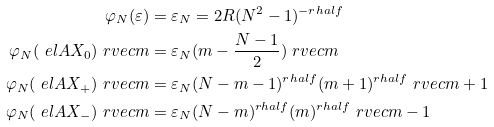Convert formula to latex. <formula><loc_0><loc_0><loc_500><loc_500>\varphi _ { N } ( \varepsilon ) & = \varepsilon _ { N } = 2 R ( N ^ { 2 } - 1 ) ^ { - r h a l f } \\ \varphi _ { N } ( \ e l A X _ { 0 } ) \ r v e c { m } & = \varepsilon _ { N } ( m - \frac { N - 1 } 2 ) \ r v e c { m } \\ \varphi _ { N } ( \ e l A X _ { + } ) \ r v e c { m } & = \varepsilon _ { N } ( N - m - 1 ) ^ { r h a l f } ( m + 1 ) ^ { r h a l f } \ r v e c { m + 1 } \\ \varphi _ { N } ( \ e l A X _ { - } ) \ r v e c { m } & = \varepsilon _ { N } ( N - m ) ^ { r h a l f } ( m ) ^ { r h a l f } \ r v e c { m - 1 }</formula> 